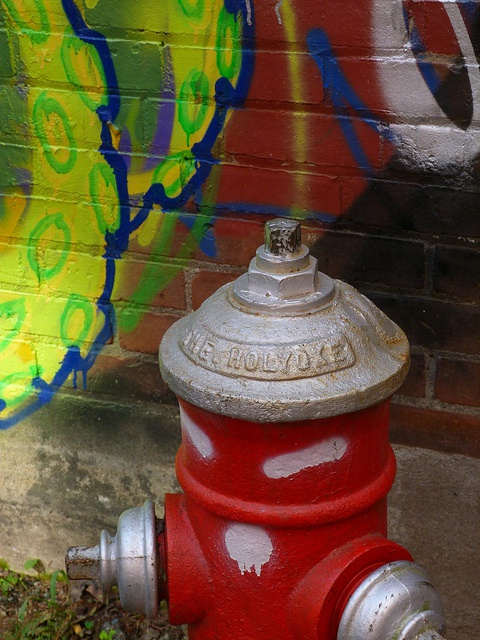Describe the objects in this image and their specific colors. I can see a fire hydrant in darkgreen, maroon, darkgray, and gray tones in this image. 